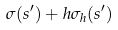Convert formula to latex. <formula><loc_0><loc_0><loc_500><loc_500>\sigma ( s ^ { \prime } ) + h \sigma _ { h } ( s ^ { \prime } )</formula> 